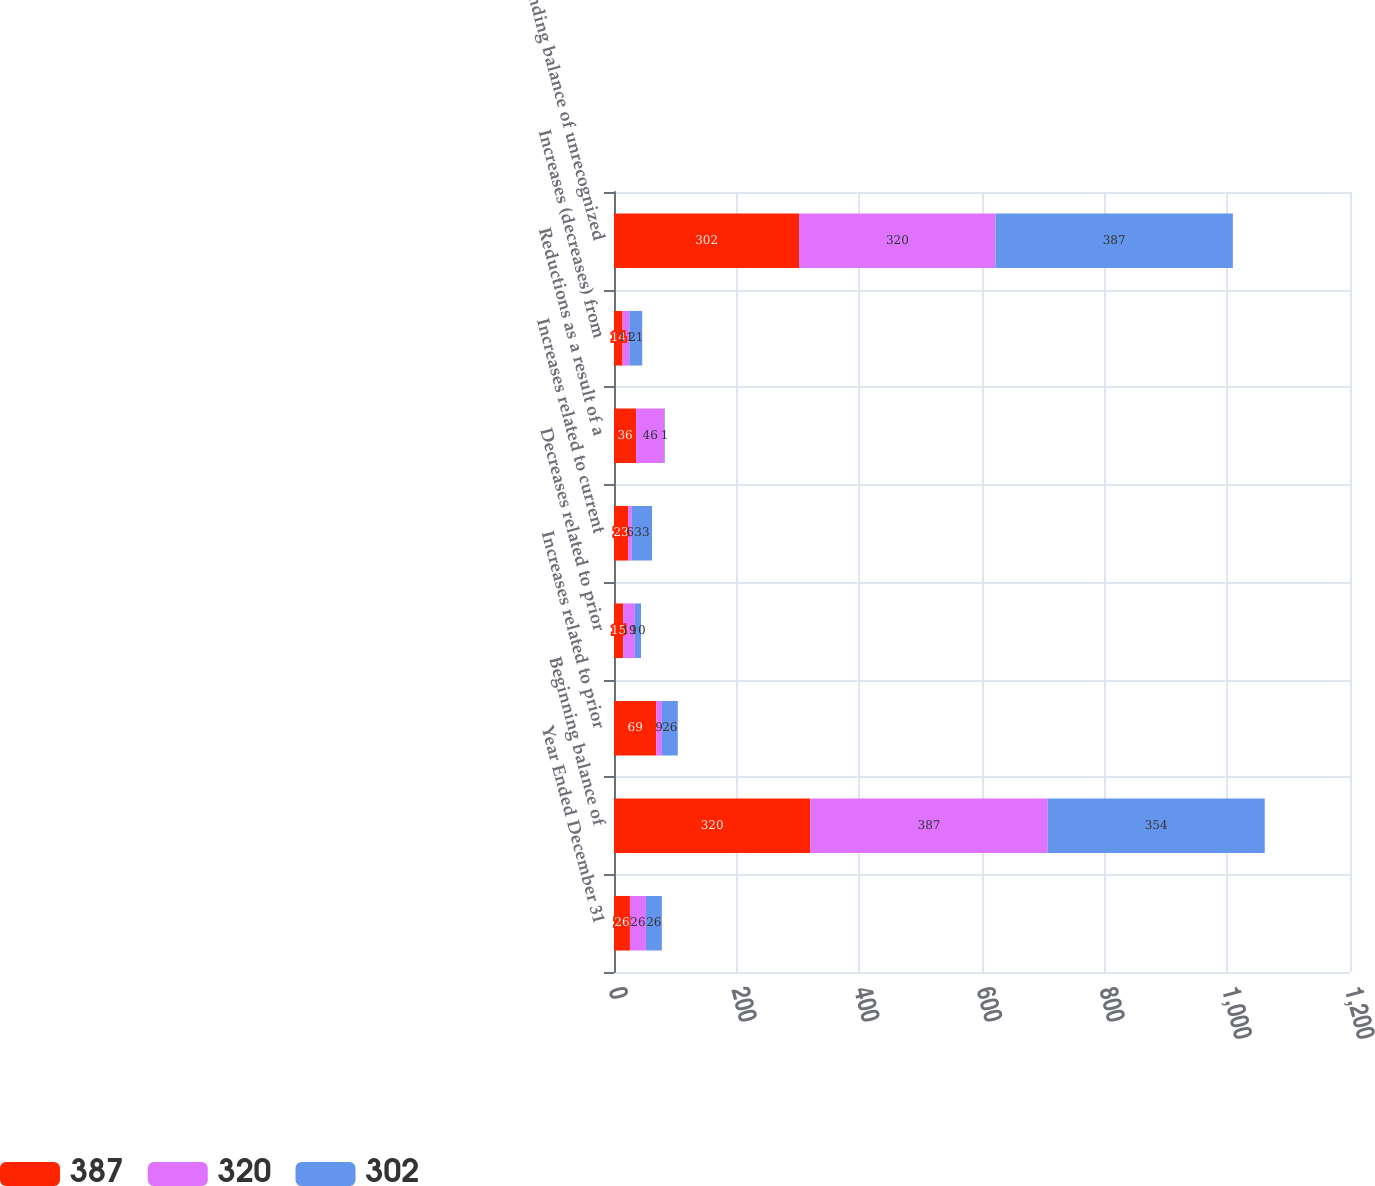Convert chart to OTSL. <chart><loc_0><loc_0><loc_500><loc_500><stacked_bar_chart><ecel><fcel>Year Ended December 31<fcel>Beginning balance of<fcel>Increases related to prior<fcel>Decreases related to prior<fcel>Increases related to current<fcel>Reductions as a result of a<fcel>Increases (decreases) from<fcel>Ending balance of unrecognized<nl><fcel>387<fcel>26<fcel>320<fcel>69<fcel>15<fcel>23<fcel>36<fcel>14<fcel>302<nl><fcel>320<fcel>26<fcel>387<fcel>9<fcel>19<fcel>6<fcel>46<fcel>11<fcel>320<nl><fcel>302<fcel>26<fcel>354<fcel>26<fcel>10<fcel>33<fcel>1<fcel>21<fcel>387<nl></chart> 